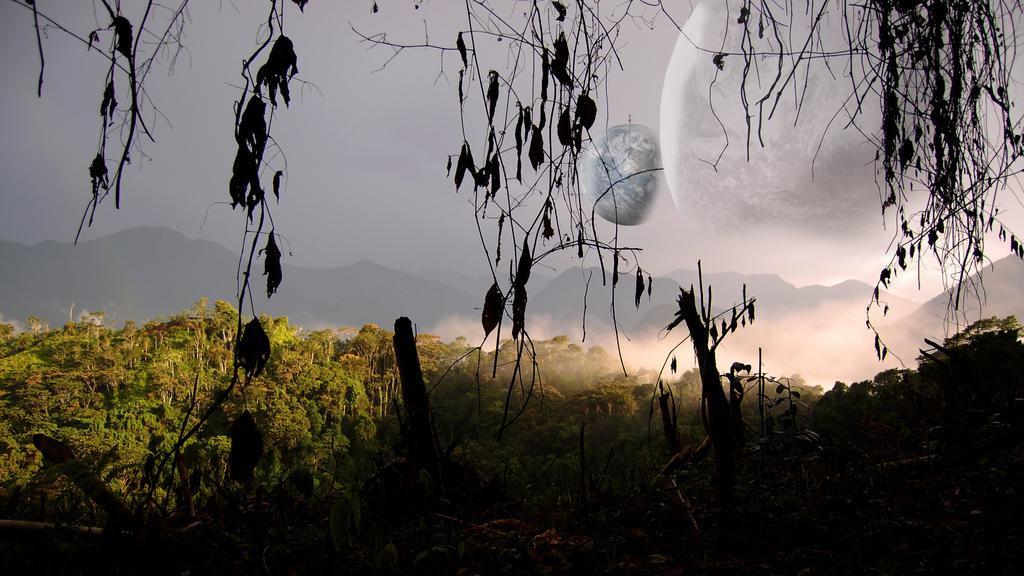What type of vegetation is present at the bottom of the image? There are trees at the bottom of the image. Can you describe the background of the image? There are trees in the background of the image. What is visible at the top of the image? The sky is visible at the top of the image. What celestial bodies can be seen in the sky? The moon and the Earth are visible in the sky. Can you tell me how much the monkey owes for the payment of the trees in the image? There is no monkey or payment present in the image; it features trees and celestial bodies in the sky. What type of activity is the monkey performing with the trees in the image? There is no monkey or activity involving trees present in the image. 